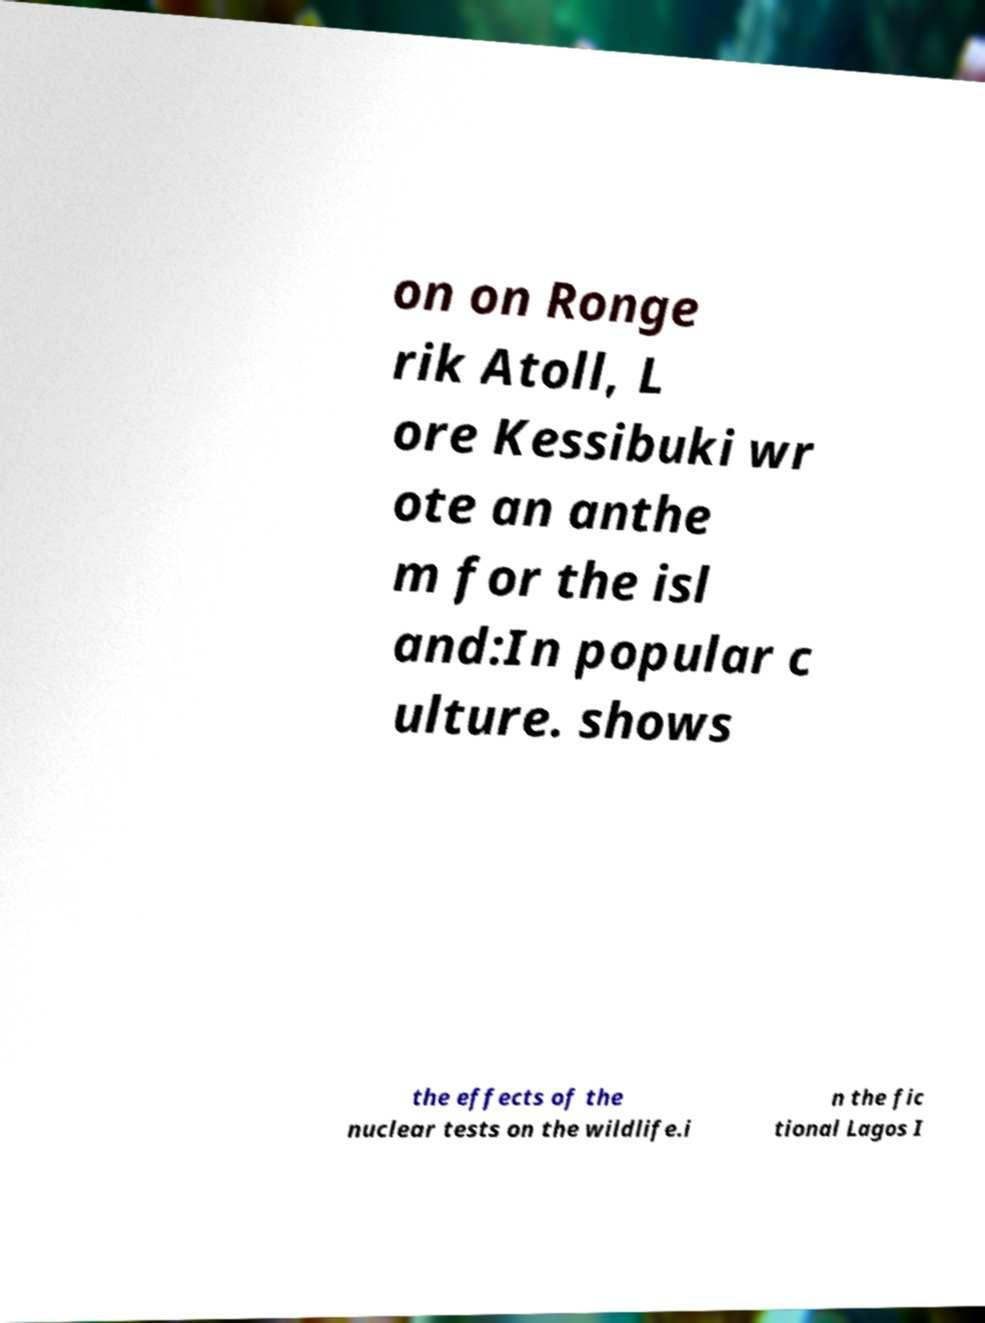There's text embedded in this image that I need extracted. Can you transcribe it verbatim? on on Ronge rik Atoll, L ore Kessibuki wr ote an anthe m for the isl and:In popular c ulture. shows the effects of the nuclear tests on the wildlife.i n the fic tional Lagos I 